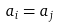<formula> <loc_0><loc_0><loc_500><loc_500>a _ { i } = a _ { j }</formula> 